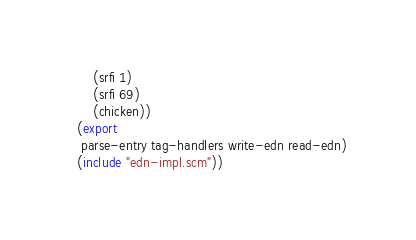Convert code to text. <code><loc_0><loc_0><loc_500><loc_500><_Scheme_>	  (srfi 1)
	  (srfi 69)
	  (chicken))
  (export
   parse-entry tag-handlers write-edn read-edn)
  (include "edn-impl.scm"))
</code> 